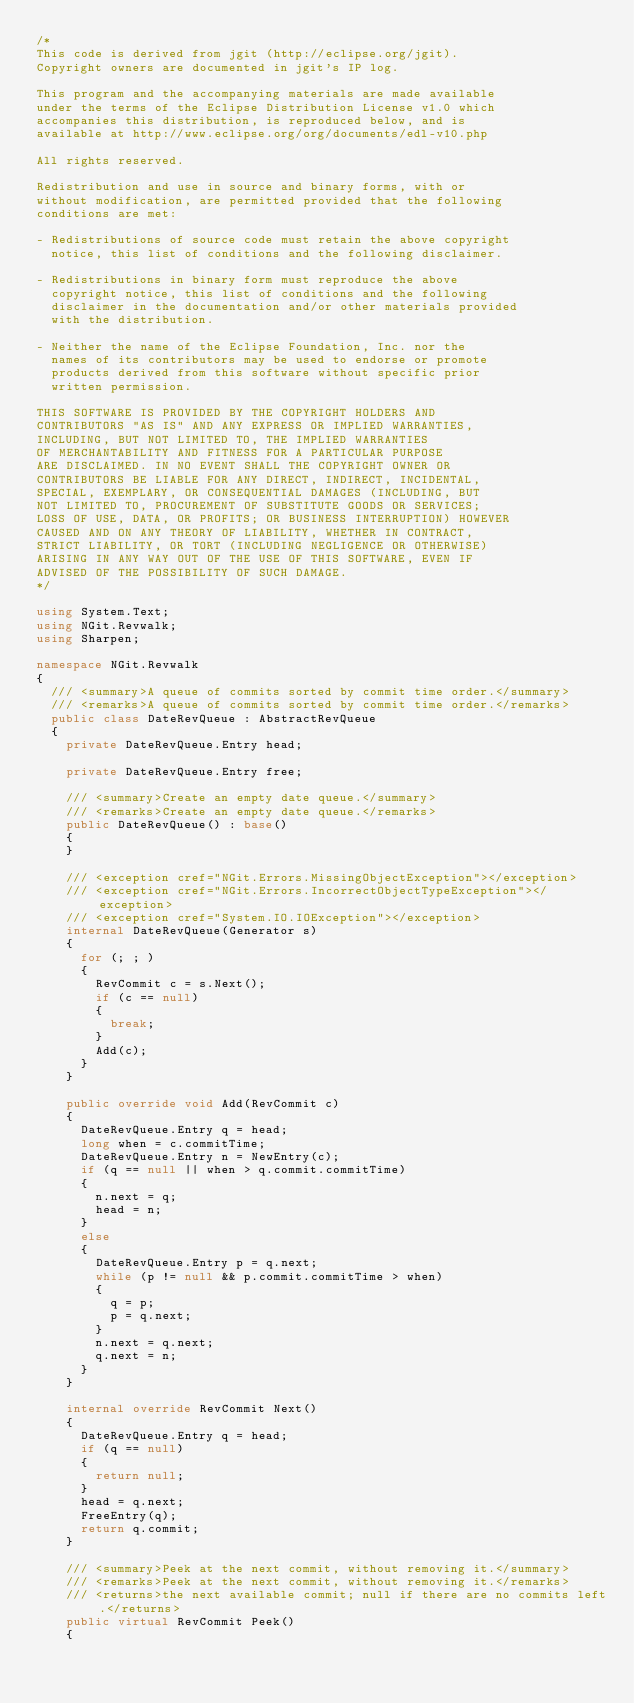<code> <loc_0><loc_0><loc_500><loc_500><_C#_>/*
This code is derived from jgit (http://eclipse.org/jgit).
Copyright owners are documented in jgit's IP log.

This program and the accompanying materials are made available
under the terms of the Eclipse Distribution License v1.0 which
accompanies this distribution, is reproduced below, and is
available at http://www.eclipse.org/org/documents/edl-v10.php

All rights reserved.

Redistribution and use in source and binary forms, with or
without modification, are permitted provided that the following
conditions are met:

- Redistributions of source code must retain the above copyright
  notice, this list of conditions and the following disclaimer.

- Redistributions in binary form must reproduce the above
  copyright notice, this list of conditions and the following
  disclaimer in the documentation and/or other materials provided
  with the distribution.

- Neither the name of the Eclipse Foundation, Inc. nor the
  names of its contributors may be used to endorse or promote
  products derived from this software without specific prior
  written permission.

THIS SOFTWARE IS PROVIDED BY THE COPYRIGHT HOLDERS AND
CONTRIBUTORS "AS IS" AND ANY EXPRESS OR IMPLIED WARRANTIES,
INCLUDING, BUT NOT LIMITED TO, THE IMPLIED WARRANTIES
OF MERCHANTABILITY AND FITNESS FOR A PARTICULAR PURPOSE
ARE DISCLAIMED. IN NO EVENT SHALL THE COPYRIGHT OWNER OR
CONTRIBUTORS BE LIABLE FOR ANY DIRECT, INDIRECT, INCIDENTAL,
SPECIAL, EXEMPLARY, OR CONSEQUENTIAL DAMAGES (INCLUDING, BUT
NOT LIMITED TO, PROCUREMENT OF SUBSTITUTE GOODS OR SERVICES;
LOSS OF USE, DATA, OR PROFITS; OR BUSINESS INTERRUPTION) HOWEVER
CAUSED AND ON ANY THEORY OF LIABILITY, WHETHER IN CONTRACT,
STRICT LIABILITY, OR TORT (INCLUDING NEGLIGENCE OR OTHERWISE)
ARISING IN ANY WAY OUT OF THE USE OF THIS SOFTWARE, EVEN IF
ADVISED OF THE POSSIBILITY OF SUCH DAMAGE.
*/

using System.Text;
using NGit.Revwalk;
using Sharpen;

namespace NGit.Revwalk
{
	/// <summary>A queue of commits sorted by commit time order.</summary>
	/// <remarks>A queue of commits sorted by commit time order.</remarks>
	public class DateRevQueue : AbstractRevQueue
	{
		private DateRevQueue.Entry head;

		private DateRevQueue.Entry free;

		/// <summary>Create an empty date queue.</summary>
		/// <remarks>Create an empty date queue.</remarks>
		public DateRevQueue() : base()
		{
		}

		/// <exception cref="NGit.Errors.MissingObjectException"></exception>
		/// <exception cref="NGit.Errors.IncorrectObjectTypeException"></exception>
		/// <exception cref="System.IO.IOException"></exception>
		internal DateRevQueue(Generator s)
		{
			for (; ; )
			{
				RevCommit c = s.Next();
				if (c == null)
				{
					break;
				}
				Add(c);
			}
		}

		public override void Add(RevCommit c)
		{
			DateRevQueue.Entry q = head;
			long when = c.commitTime;
			DateRevQueue.Entry n = NewEntry(c);
			if (q == null || when > q.commit.commitTime)
			{
				n.next = q;
				head = n;
			}
			else
			{
				DateRevQueue.Entry p = q.next;
				while (p != null && p.commit.commitTime > when)
				{
					q = p;
					p = q.next;
				}
				n.next = q.next;
				q.next = n;
			}
		}

		internal override RevCommit Next()
		{
			DateRevQueue.Entry q = head;
			if (q == null)
			{
				return null;
			}
			head = q.next;
			FreeEntry(q);
			return q.commit;
		}

		/// <summary>Peek at the next commit, without removing it.</summary>
		/// <remarks>Peek at the next commit, without removing it.</remarks>
		/// <returns>the next available commit; null if there are no commits left.</returns>
		public virtual RevCommit Peek()
		{</code> 